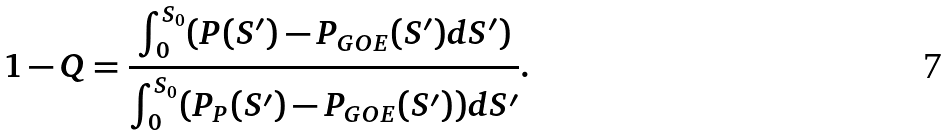<formula> <loc_0><loc_0><loc_500><loc_500>1 - Q = \frac { \int _ { 0 } ^ { S _ { 0 } } ( P ( S ^ { \prime } ) - P _ { G O E } ( S ^ { \prime } ) d S ^ { \prime } ) } { \int _ { 0 } ^ { S _ { 0 } } ( P _ { P } ( S ^ { \prime } ) - P _ { G O E } ( S ^ { \prime } ) ) d S ^ { \prime } } .</formula> 